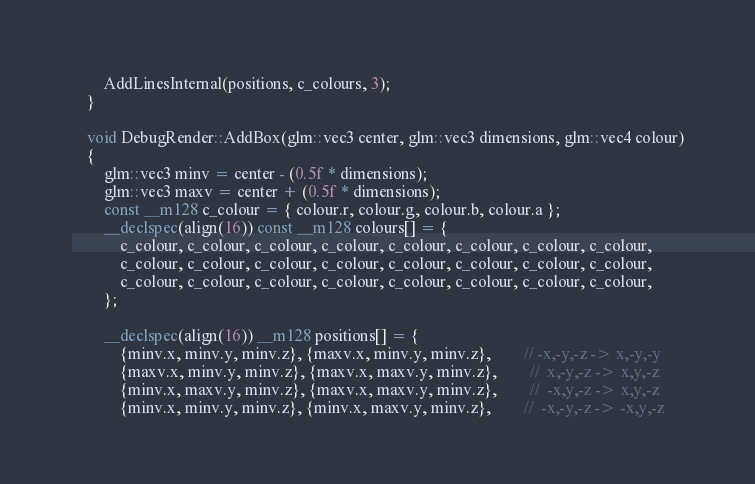<code> <loc_0><loc_0><loc_500><loc_500><_C++_>
		AddLinesInternal(positions, c_colours, 3);
	}

	void DebugRender::AddBox(glm::vec3 center, glm::vec3 dimensions, glm::vec4 colour)
	{
		glm::vec3 minv = center - (0.5f * dimensions);
		glm::vec3 maxv = center + (0.5f * dimensions);
		const __m128 c_colour = { colour.r, colour.g, colour.b, colour.a };
		__declspec(align(16)) const __m128 colours[] = {
			c_colour, c_colour, c_colour, c_colour, c_colour, c_colour, c_colour, c_colour,
			c_colour, c_colour, c_colour, c_colour, c_colour, c_colour, c_colour, c_colour,
			c_colour, c_colour, c_colour, c_colour, c_colour, c_colour, c_colour, c_colour,
		};

		__declspec(align(16)) __m128 positions[] = {
			{minv.x, minv.y, minv.z}, {maxv.x, minv.y, minv.z},		// -x,-y,-z -> x,-y,-y
			{maxv.x, minv.y, minv.z}, {maxv.x, maxv.y, minv.z},		//  x,-y,-z -> x,y,-z
			{minv.x, maxv.y, minv.z}, {maxv.x, maxv.y, minv.z},		//  -x,y,-z -> x,y,-z
			{minv.x, minv.y, minv.z}, {minv.x, maxv.y, minv.z},		//  -x,-y,-z -> -x,y,-z
</code> 